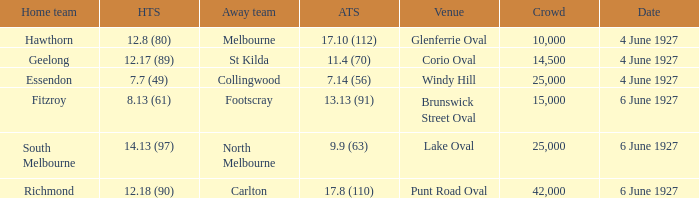How many people in the crowd with north melbourne as an away team? 25000.0. 